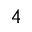<formula> <loc_0><loc_0><loc_500><loc_500>_ { 4 }</formula> 